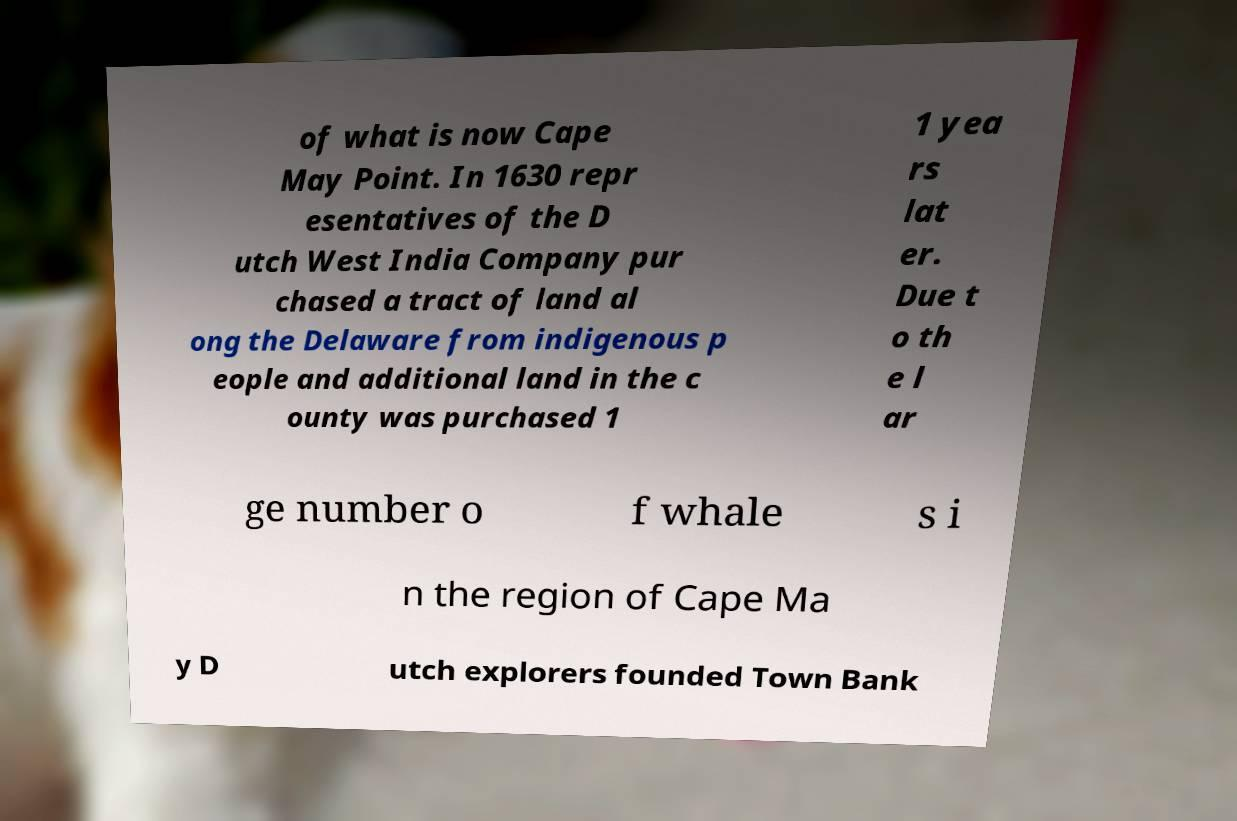Can you read and provide the text displayed in the image?This photo seems to have some interesting text. Can you extract and type it out for me? of what is now Cape May Point. In 1630 repr esentatives of the D utch West India Company pur chased a tract of land al ong the Delaware from indigenous p eople and additional land in the c ounty was purchased 1 1 yea rs lat er. Due t o th e l ar ge number o f whale s i n the region of Cape Ma y D utch explorers founded Town Bank 